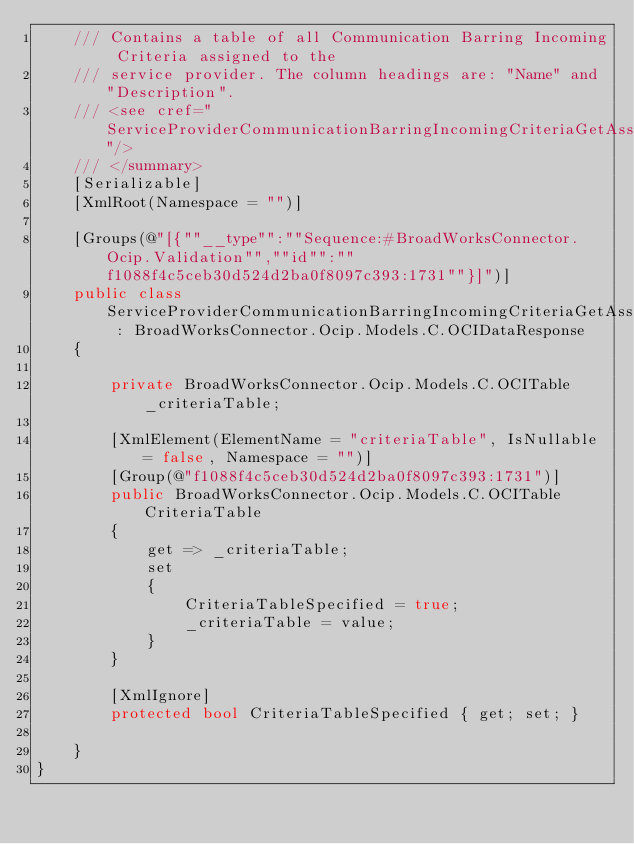Convert code to text. <code><loc_0><loc_0><loc_500><loc_500><_C#_>    /// Contains a table of all Communication Barring Incoming Criteria assigned to the
    /// service provider. The column headings are: "Name" and "Description".
    /// <see cref="ServiceProviderCommunicationBarringIncomingCriteriaGetAssignedListRequest"/>
    /// </summary>
    [Serializable]
    [XmlRoot(Namespace = "")]

    [Groups(@"[{""__type"":""Sequence:#BroadWorksConnector.Ocip.Validation"",""id"":""f1088f4c5ceb30d524d2ba0f8097c393:1731""}]")]
    public class ServiceProviderCommunicationBarringIncomingCriteriaGetAssignedListResponse : BroadWorksConnector.Ocip.Models.C.OCIDataResponse
    {

        private BroadWorksConnector.Ocip.Models.C.OCITable _criteriaTable;

        [XmlElement(ElementName = "criteriaTable", IsNullable = false, Namespace = "")]
        [Group(@"f1088f4c5ceb30d524d2ba0f8097c393:1731")]
        public BroadWorksConnector.Ocip.Models.C.OCITable CriteriaTable
        {
            get => _criteriaTable;
            set
            {
                CriteriaTableSpecified = true;
                _criteriaTable = value;
            }
        }

        [XmlIgnore]
        protected bool CriteriaTableSpecified { get; set; }

    }
}
</code> 